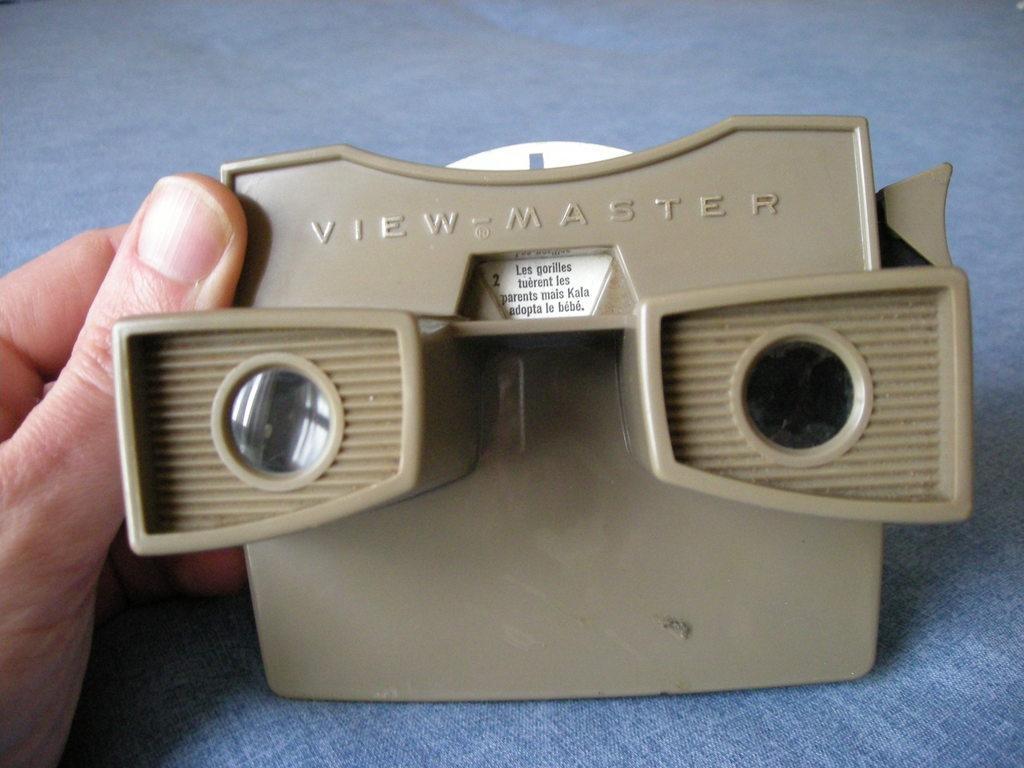Describe this image in one or two sentences. In this image we can see a person's hand with an object. On the object something is written. And it is on a blue surface. 